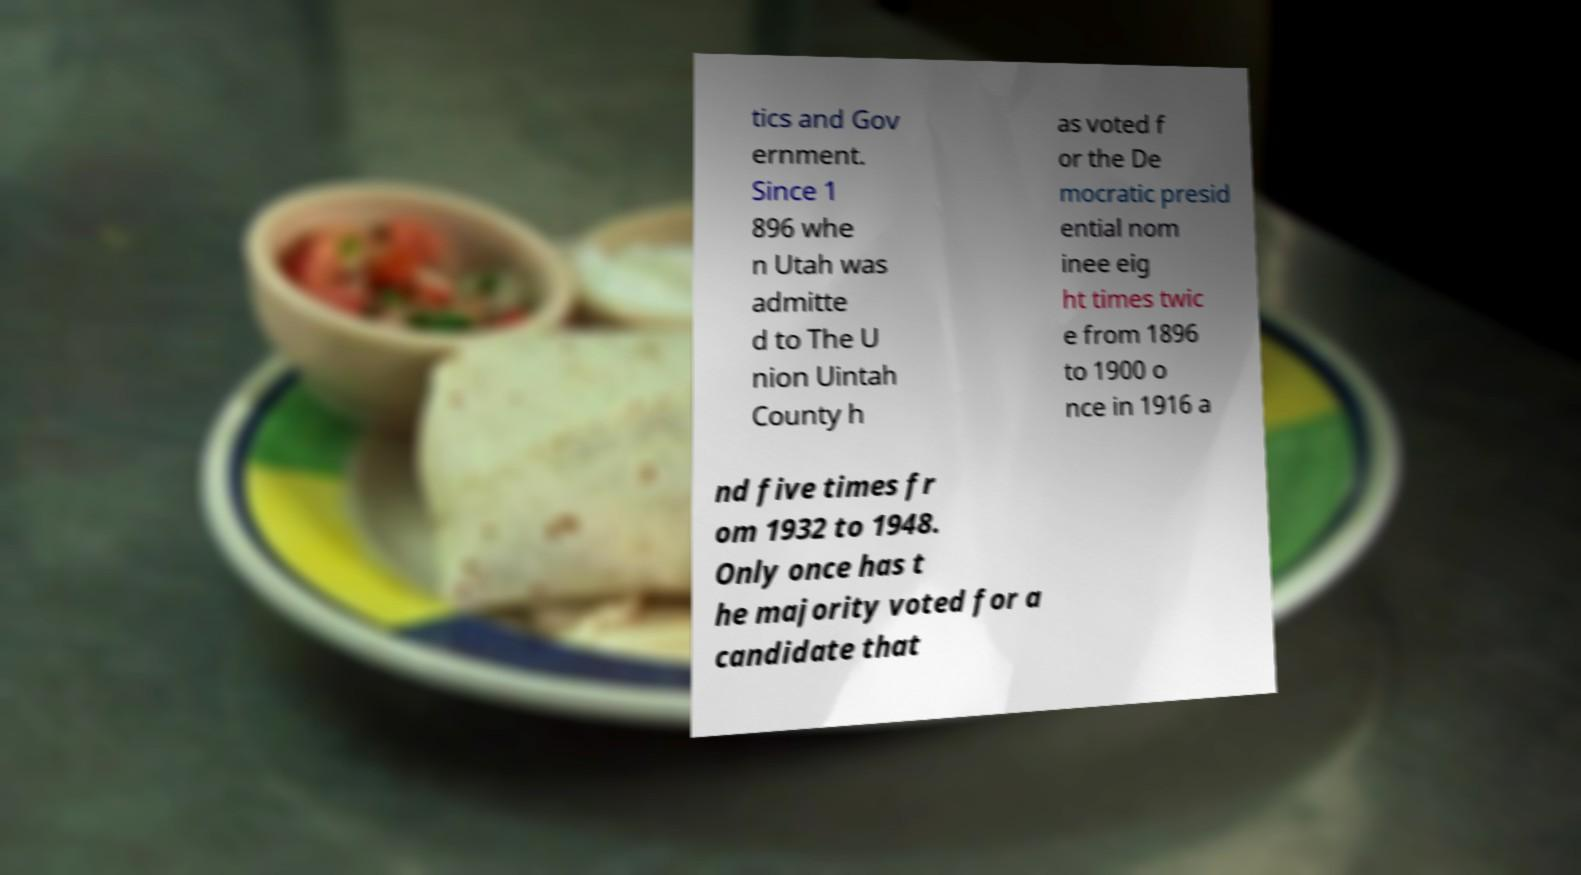Could you extract and type out the text from this image? tics and Gov ernment. Since 1 896 whe n Utah was admitte d to The U nion Uintah County h as voted f or the De mocratic presid ential nom inee eig ht times twic e from 1896 to 1900 o nce in 1916 a nd five times fr om 1932 to 1948. Only once has t he majority voted for a candidate that 